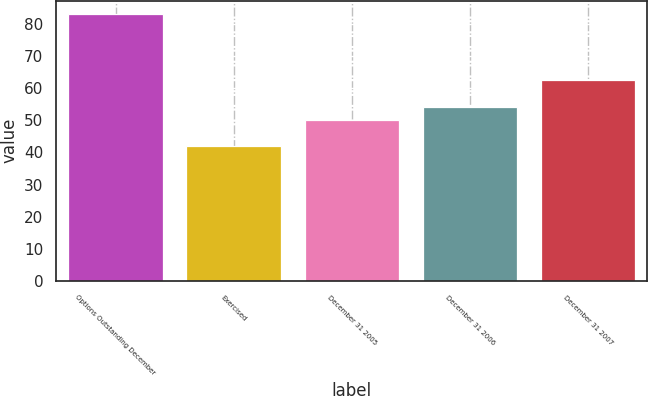<chart> <loc_0><loc_0><loc_500><loc_500><bar_chart><fcel>Options Outstanding December<fcel>Exercised<fcel>December 31 2005<fcel>December 31 2006<fcel>December 31 2007<nl><fcel>83.15<fcel>41.89<fcel>50.15<fcel>54.28<fcel>62.54<nl></chart> 